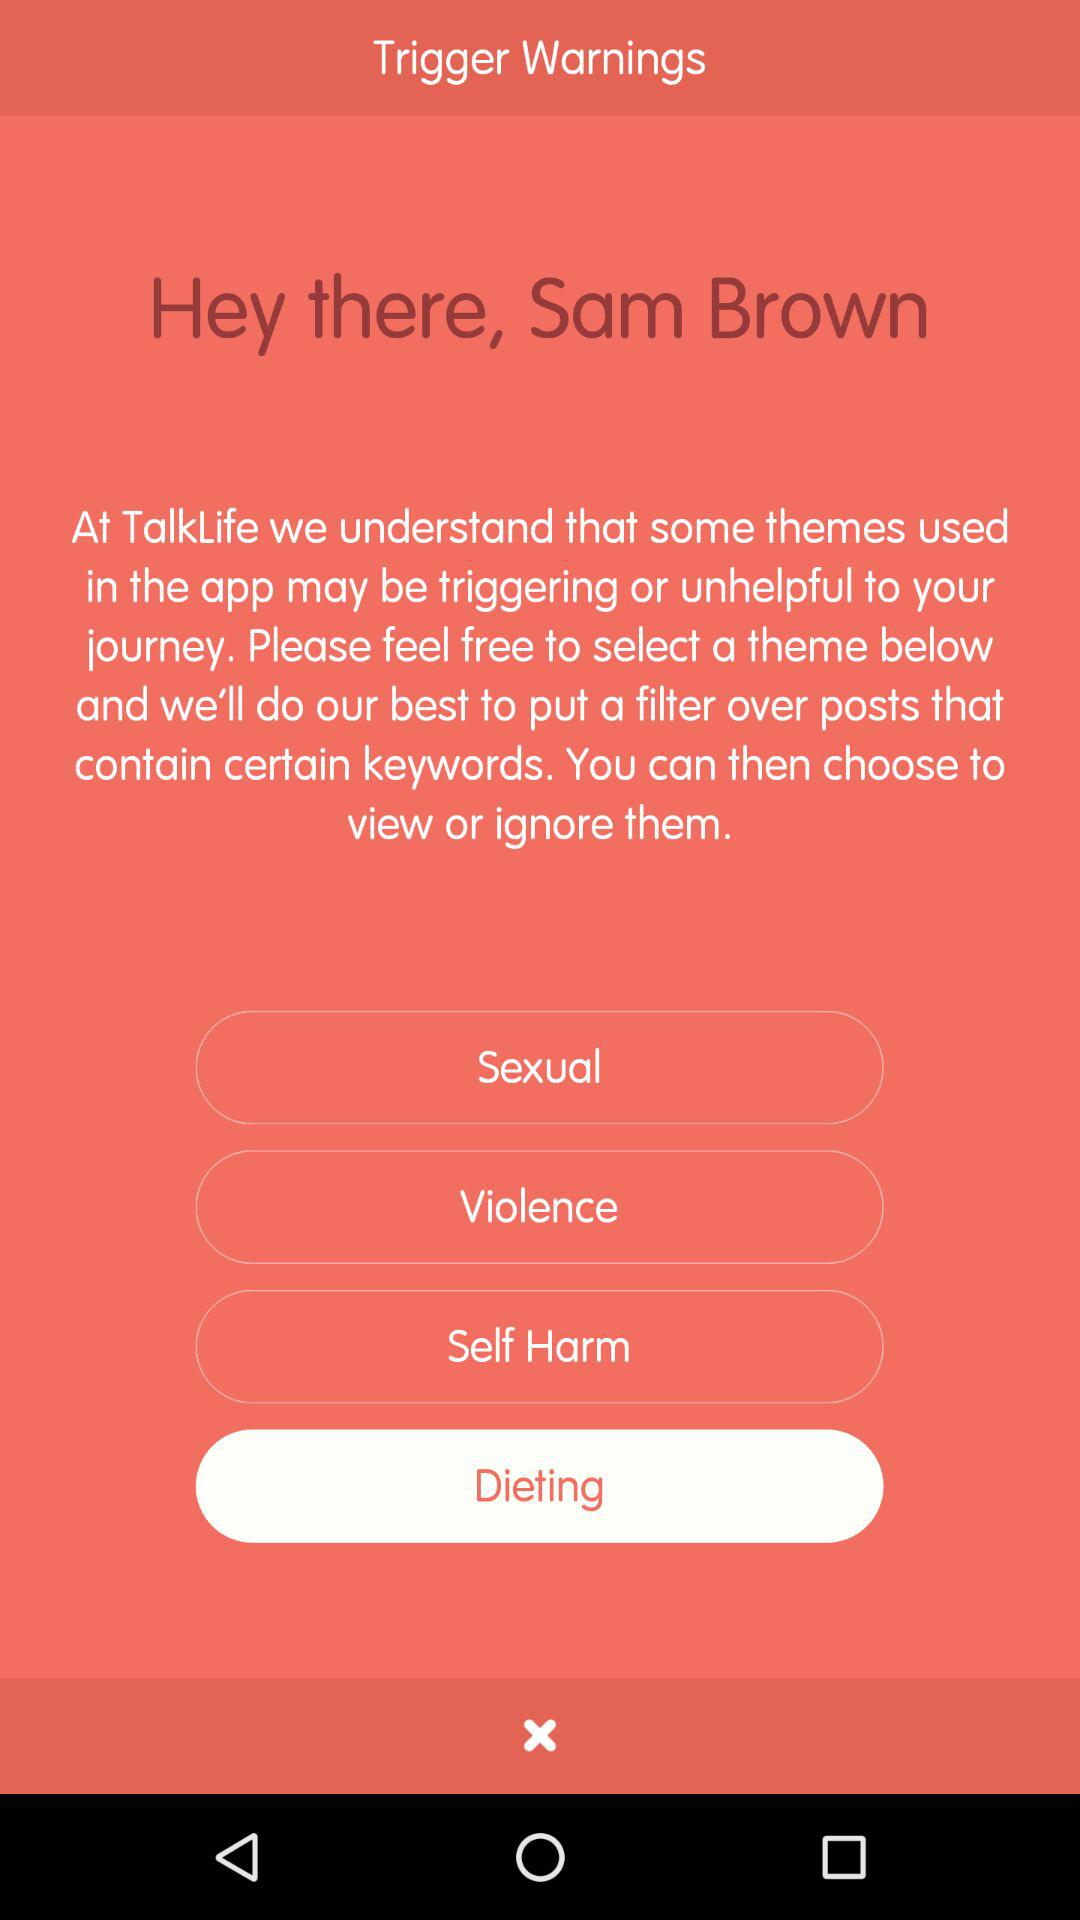How many themes are there in the Trigger Warnings section?
Answer the question using a single word or phrase. 4 